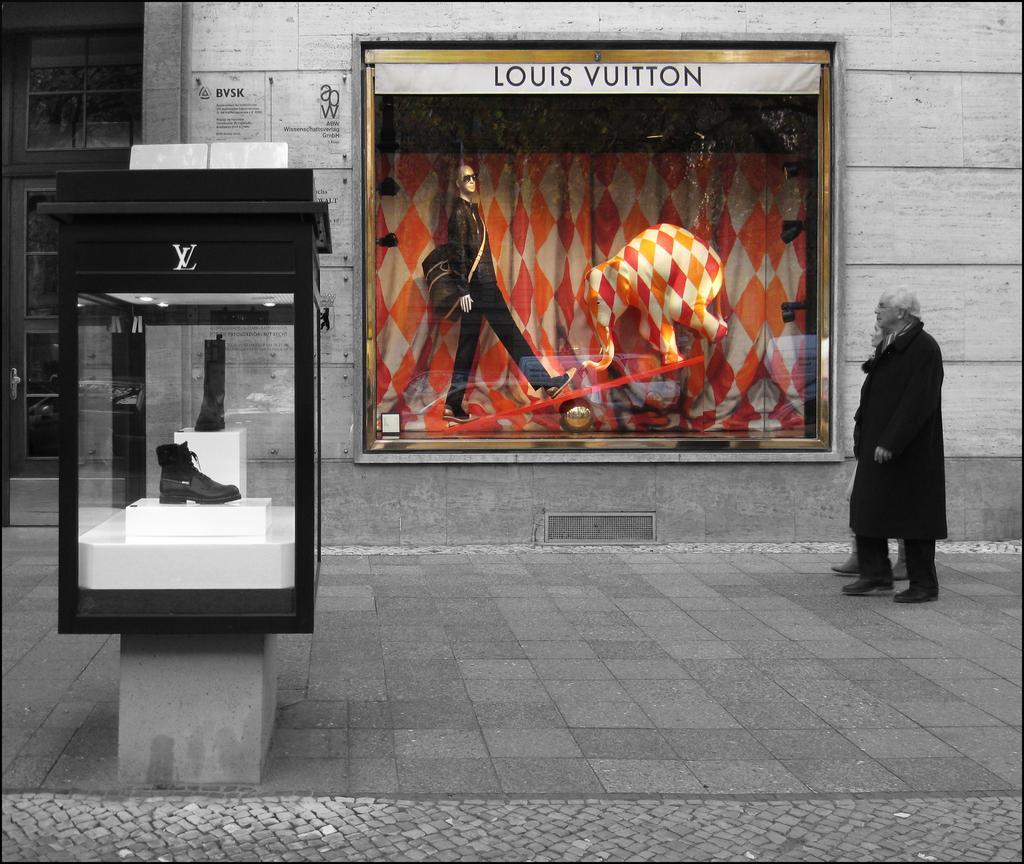Describe this image in one or two sentences. In the background we can see the wall and a door. In this picture we can see boards with some information. Through the glass we can see mannequin, few objects and depiction of an elephant. On the right side of the picture we can see people walking on the road. On the left side of the picture we can see footwear displayed in a glass box. 